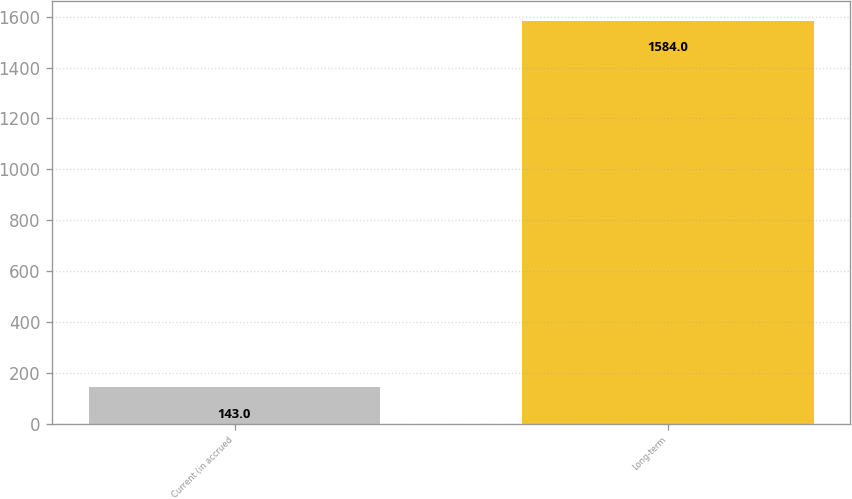<chart> <loc_0><loc_0><loc_500><loc_500><bar_chart><fcel>Current (in accrued<fcel>Long-term<nl><fcel>143<fcel>1584<nl></chart> 